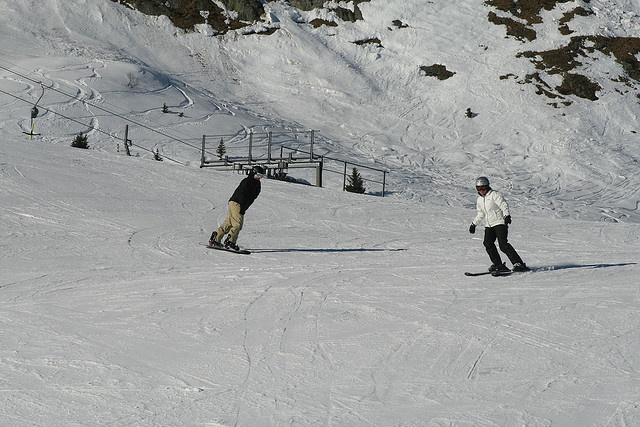Describe the objects in this image and their specific colors. I can see people in darkgray, black, lightgray, and gray tones, people in darkgray, black, gray, and tan tones, skis in darkgray, black, and gray tones, and snowboard in darkgray, black, and gray tones in this image. 